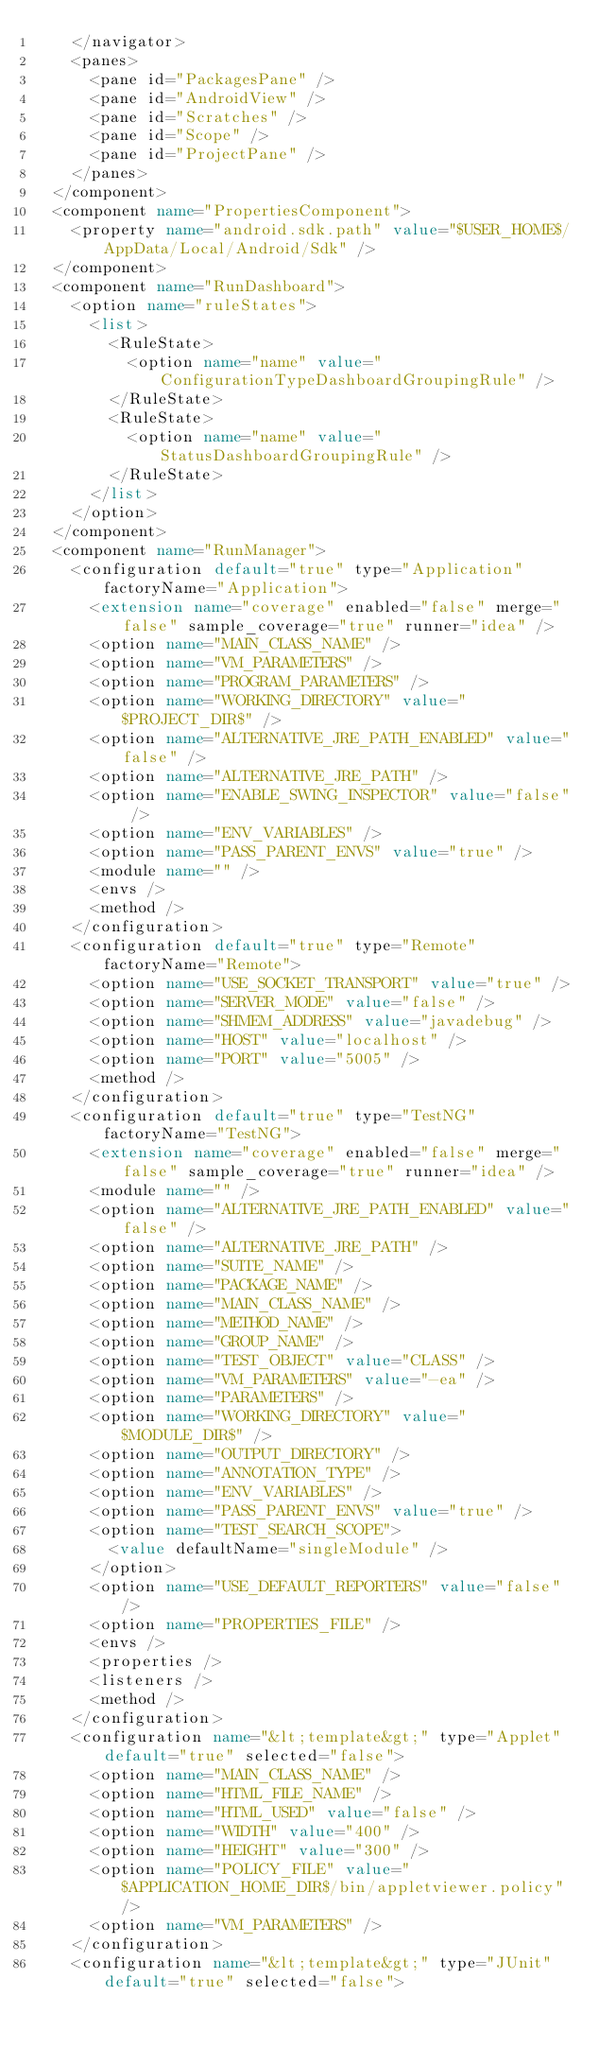<code> <loc_0><loc_0><loc_500><loc_500><_XML_>    </navigator>
    <panes>
      <pane id="PackagesPane" />
      <pane id="AndroidView" />
      <pane id="Scratches" />
      <pane id="Scope" />
      <pane id="ProjectPane" />
    </panes>
  </component>
  <component name="PropertiesComponent">
    <property name="android.sdk.path" value="$USER_HOME$/AppData/Local/Android/Sdk" />
  </component>
  <component name="RunDashboard">
    <option name="ruleStates">
      <list>
        <RuleState>
          <option name="name" value="ConfigurationTypeDashboardGroupingRule" />
        </RuleState>
        <RuleState>
          <option name="name" value="StatusDashboardGroupingRule" />
        </RuleState>
      </list>
    </option>
  </component>
  <component name="RunManager">
    <configuration default="true" type="Application" factoryName="Application">
      <extension name="coverage" enabled="false" merge="false" sample_coverage="true" runner="idea" />
      <option name="MAIN_CLASS_NAME" />
      <option name="VM_PARAMETERS" />
      <option name="PROGRAM_PARAMETERS" />
      <option name="WORKING_DIRECTORY" value="$PROJECT_DIR$" />
      <option name="ALTERNATIVE_JRE_PATH_ENABLED" value="false" />
      <option name="ALTERNATIVE_JRE_PATH" />
      <option name="ENABLE_SWING_INSPECTOR" value="false" />
      <option name="ENV_VARIABLES" />
      <option name="PASS_PARENT_ENVS" value="true" />
      <module name="" />
      <envs />
      <method />
    </configuration>
    <configuration default="true" type="Remote" factoryName="Remote">
      <option name="USE_SOCKET_TRANSPORT" value="true" />
      <option name="SERVER_MODE" value="false" />
      <option name="SHMEM_ADDRESS" value="javadebug" />
      <option name="HOST" value="localhost" />
      <option name="PORT" value="5005" />
      <method />
    </configuration>
    <configuration default="true" type="TestNG" factoryName="TestNG">
      <extension name="coverage" enabled="false" merge="false" sample_coverage="true" runner="idea" />
      <module name="" />
      <option name="ALTERNATIVE_JRE_PATH_ENABLED" value="false" />
      <option name="ALTERNATIVE_JRE_PATH" />
      <option name="SUITE_NAME" />
      <option name="PACKAGE_NAME" />
      <option name="MAIN_CLASS_NAME" />
      <option name="METHOD_NAME" />
      <option name="GROUP_NAME" />
      <option name="TEST_OBJECT" value="CLASS" />
      <option name="VM_PARAMETERS" value="-ea" />
      <option name="PARAMETERS" />
      <option name="WORKING_DIRECTORY" value="$MODULE_DIR$" />
      <option name="OUTPUT_DIRECTORY" />
      <option name="ANNOTATION_TYPE" />
      <option name="ENV_VARIABLES" />
      <option name="PASS_PARENT_ENVS" value="true" />
      <option name="TEST_SEARCH_SCOPE">
        <value defaultName="singleModule" />
      </option>
      <option name="USE_DEFAULT_REPORTERS" value="false" />
      <option name="PROPERTIES_FILE" />
      <envs />
      <properties />
      <listeners />
      <method />
    </configuration>
    <configuration name="&lt;template&gt;" type="Applet" default="true" selected="false">
      <option name="MAIN_CLASS_NAME" />
      <option name="HTML_FILE_NAME" />
      <option name="HTML_USED" value="false" />
      <option name="WIDTH" value="400" />
      <option name="HEIGHT" value="300" />
      <option name="POLICY_FILE" value="$APPLICATION_HOME_DIR$/bin/appletviewer.policy" />
      <option name="VM_PARAMETERS" />
    </configuration>
    <configuration name="&lt;template&gt;" type="JUnit" default="true" selected="false"></code> 